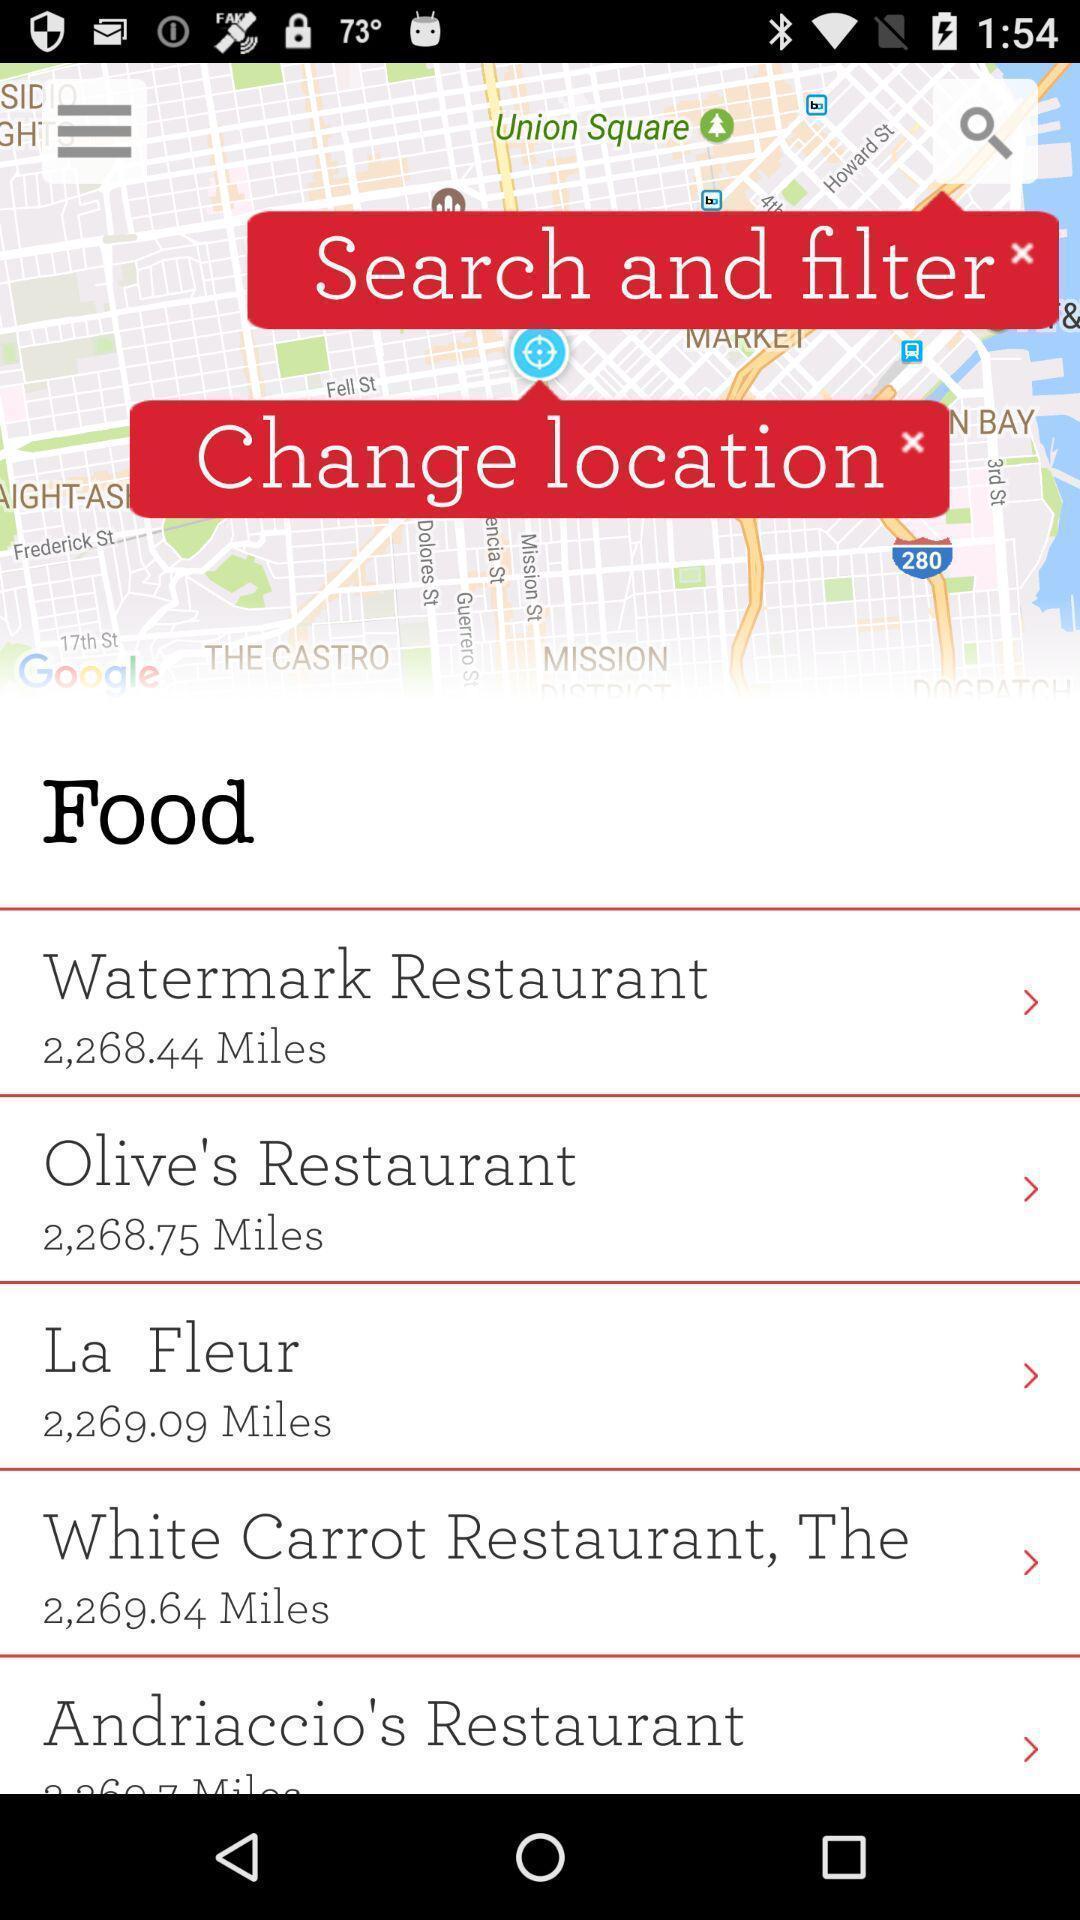Provide a detailed account of this screenshot. Screen shows list of restaurant options. 